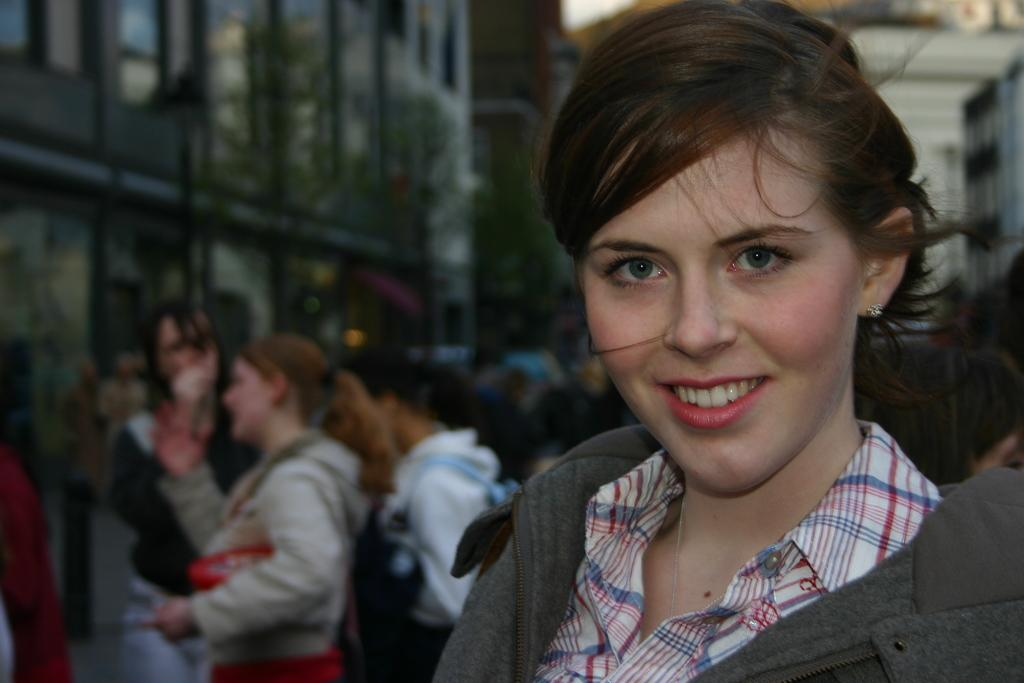Who is the main subject in the image? There is a woman in the image. Can you describe the woman's appearance? The woman has short hair. What is the woman doing in the image? The woman is looking and smiling at someone. What can be seen in the background of the image? There are many people in the background of the image. What type of vest is the woman wearing in the image? There is no vest visible in the image; the woman is not wearing one. How many babies can be seen in the image? There are no babies present in the image. 